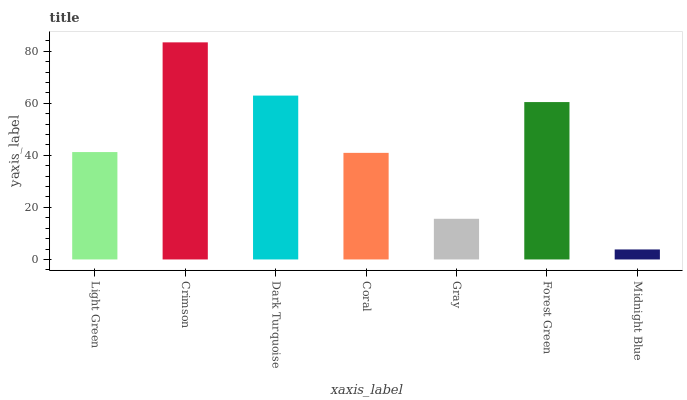Is Midnight Blue the minimum?
Answer yes or no. Yes. Is Crimson the maximum?
Answer yes or no. Yes. Is Dark Turquoise the minimum?
Answer yes or no. No. Is Dark Turquoise the maximum?
Answer yes or no. No. Is Crimson greater than Dark Turquoise?
Answer yes or no. Yes. Is Dark Turquoise less than Crimson?
Answer yes or no. Yes. Is Dark Turquoise greater than Crimson?
Answer yes or no. No. Is Crimson less than Dark Turquoise?
Answer yes or no. No. Is Light Green the high median?
Answer yes or no. Yes. Is Light Green the low median?
Answer yes or no. Yes. Is Dark Turquoise the high median?
Answer yes or no. No. Is Coral the low median?
Answer yes or no. No. 